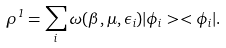<formula> <loc_0><loc_0><loc_500><loc_500>\rho ^ { 1 } = \sum _ { i } \omega ( \beta , \mu , \epsilon _ { i } ) | \phi _ { i } > < \phi _ { i } | .</formula> 